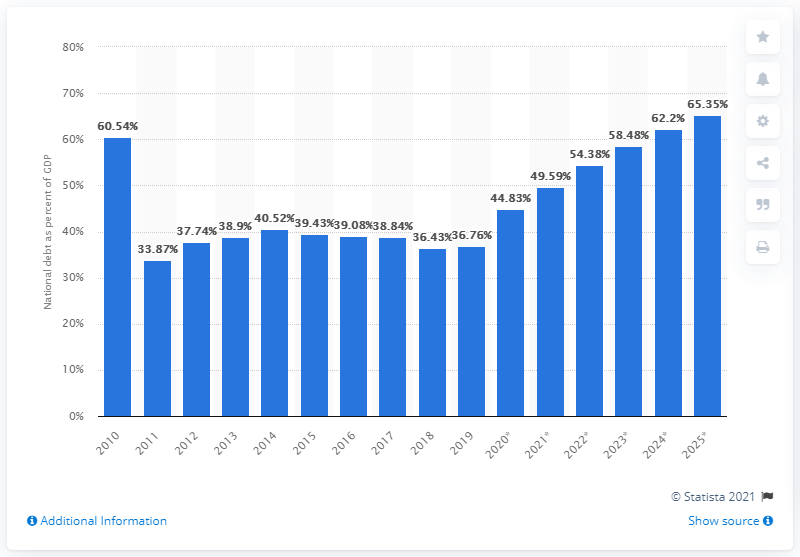Identify some key points in this picture. In 2019, the national debt of Romania accounted for 36.76% of the country's GDP. 